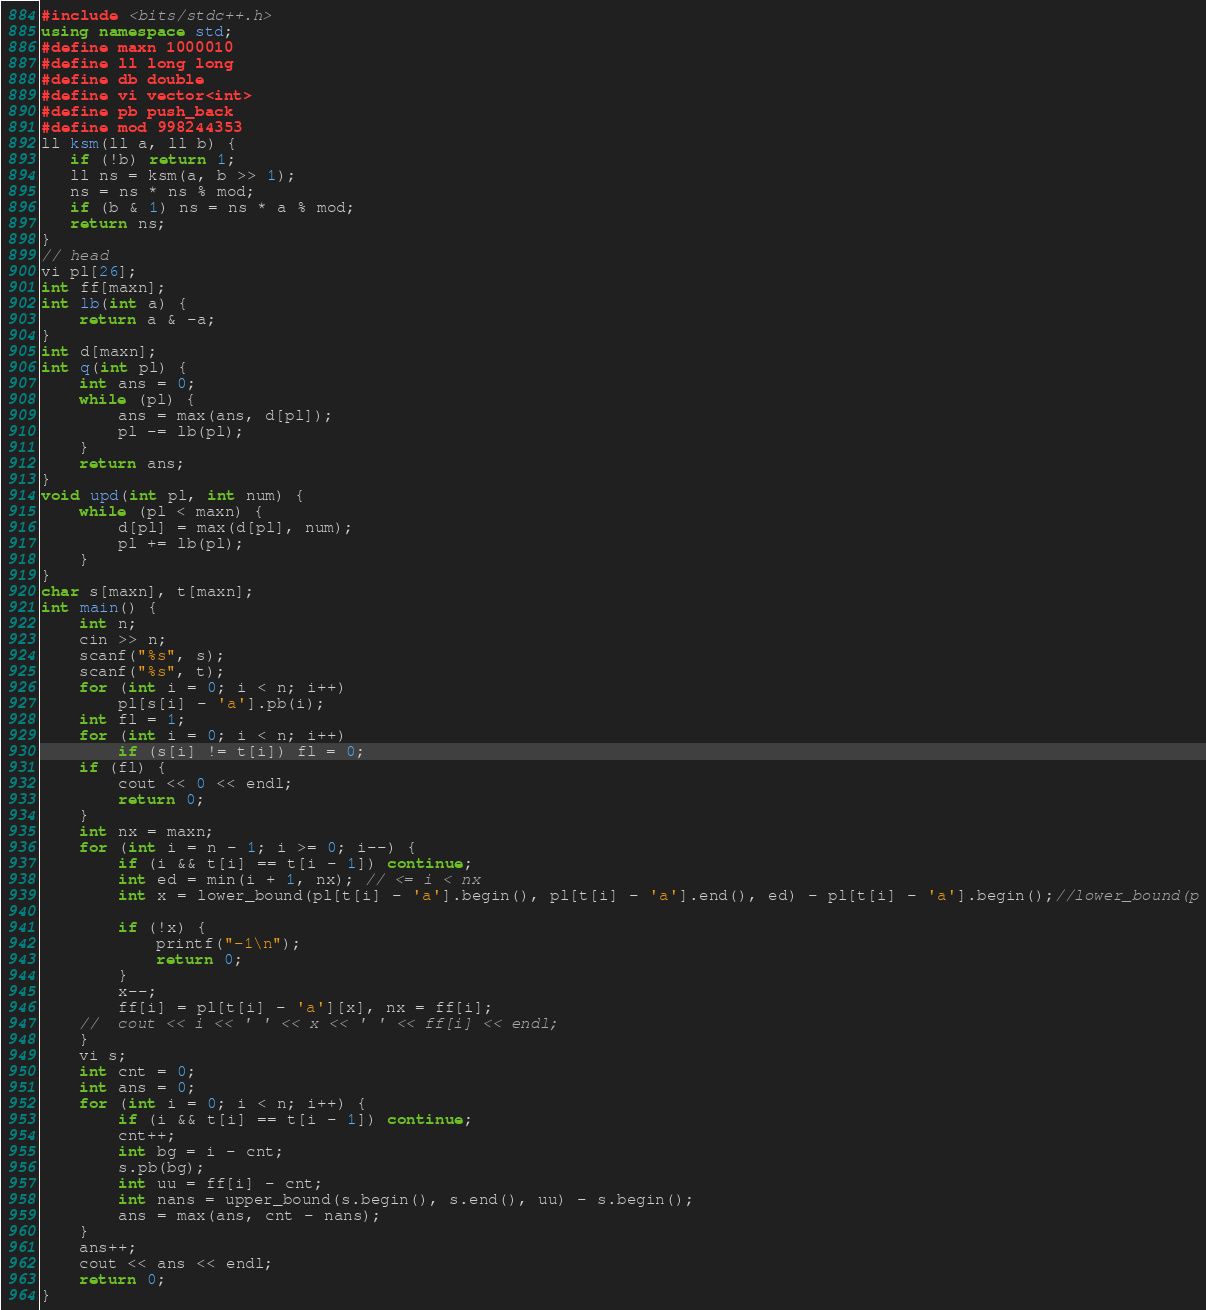<code> <loc_0><loc_0><loc_500><loc_500><_C++_>#include <bits/stdc++.h>
using namespace std;
#define maxn 1000010
#define ll long long
#define db double
#define vi vector<int>
#define pb push_back
#define mod 998244353
ll ksm(ll a, ll b) {
   if (!b) return 1;
   ll ns = ksm(a, b >> 1);
   ns = ns * ns % mod;
   if (b & 1) ns = ns * a % mod;
   return ns;
}
// head
vi pl[26];
int ff[maxn];
int lb(int a) {
	return a & -a;
}
int d[maxn];
int q(int pl) {
	int ans = 0;
	while (pl) {
		ans = max(ans, d[pl]);
		pl -= lb(pl);
	}
	return ans;
}
void upd(int pl, int num) {
	while (pl < maxn) {
		d[pl] = max(d[pl], num);
		pl += lb(pl);
	}
}
char s[maxn], t[maxn];
int main() {
	int n;
	cin >> n;
	scanf("%s", s);
	scanf("%s", t);
	for (int i = 0; i < n; i++)
		pl[s[i] - 'a'].pb(i);
	int fl = 1;
	for (int i = 0; i < n; i++)
		if (s[i] != t[i]) fl = 0;
	if (fl) {
		cout << 0 << endl;
		return 0;
	}
	int nx = maxn;
	for (int i = n - 1; i >= 0; i--) {
		if (i && t[i] == t[i - 1]) continue;
		int ed = min(i + 1, nx); // <= i < nx
		int x = lower_bound(pl[t[i] - 'a'].begin(), pl[t[i] - 'a'].end(), ed) - pl[t[i] - 'a'].begin();//lower_bound(p
	
		if (!x) {
			printf("-1\n");
			return 0;
		}
		x--;
		ff[i] = pl[t[i] - 'a'][x], nx = ff[i];	
	//	cout << i << ' ' << x << ' ' << ff[i] << endl;
	}
	vi s;
	int cnt = 0;
	int ans = 0;
	for (int i = 0; i < n; i++) {
		if (i && t[i] == t[i - 1]) continue;
		cnt++;
		int bg = i - cnt;
		s.pb(bg);
		int uu = ff[i] - cnt;
		int nans = upper_bound(s.begin(), s.end(), uu) - s.begin();
		ans = max(ans, cnt - nans);
	}
	ans++;
	cout << ans << endl;
	return 0;
}
</code> 